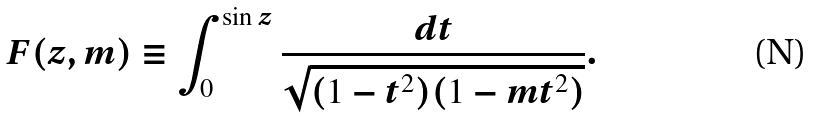<formula> <loc_0><loc_0><loc_500><loc_500>F ( z , m ) \equiv \int _ { 0 } ^ { \sin z } \frac { d t } { \sqrt { ( 1 - t ^ { 2 } ) ( 1 - m t ^ { 2 } ) } } .</formula> 